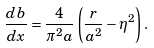<formula> <loc_0><loc_0><loc_500><loc_500>\frac { d b } { d x } = \frac { 4 } { \pi ^ { 2 } a } \left ( \frac { r } { a ^ { 2 } } - \eta ^ { 2 } \right ) .</formula> 